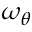Convert formula to latex. <formula><loc_0><loc_0><loc_500><loc_500>\omega _ { \theta }</formula> 